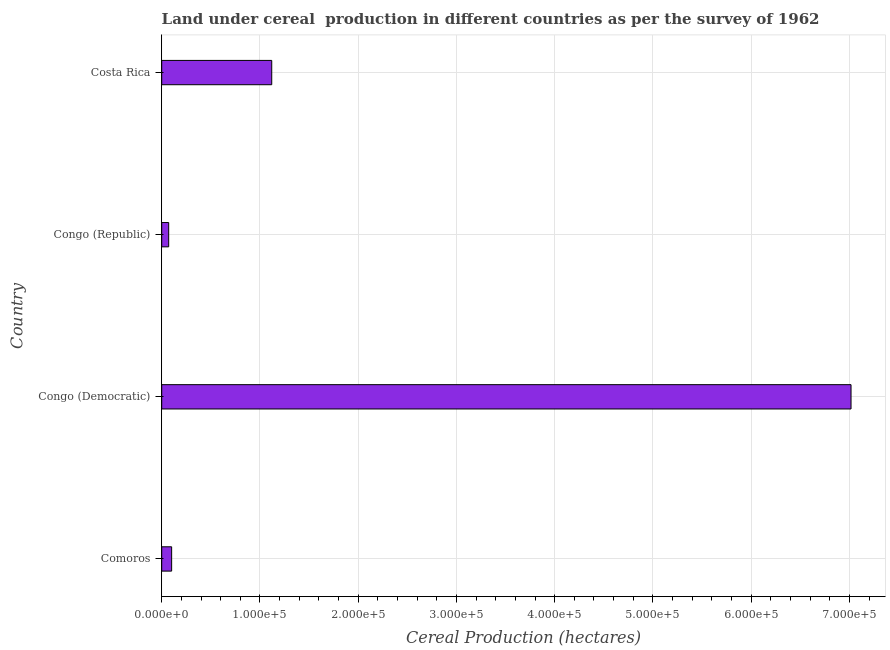What is the title of the graph?
Your answer should be compact. Land under cereal  production in different countries as per the survey of 1962. What is the label or title of the X-axis?
Make the answer very short. Cereal Production (hectares). What is the land under cereal production in Comoros?
Keep it short and to the point. 1.01e+04. Across all countries, what is the maximum land under cereal production?
Offer a terse response. 7.02e+05. Across all countries, what is the minimum land under cereal production?
Make the answer very short. 7100. In which country was the land under cereal production maximum?
Your answer should be compact. Congo (Democratic). In which country was the land under cereal production minimum?
Your answer should be compact. Congo (Republic). What is the sum of the land under cereal production?
Offer a very short reply. 8.31e+05. What is the difference between the land under cereal production in Congo (Democratic) and Congo (Republic)?
Your answer should be very brief. 6.95e+05. What is the average land under cereal production per country?
Your answer should be very brief. 2.08e+05. What is the median land under cereal production?
Offer a terse response. 6.10e+04. In how many countries, is the land under cereal production greater than 100000 hectares?
Provide a succinct answer. 2. What is the ratio of the land under cereal production in Comoros to that in Congo (Democratic)?
Your answer should be very brief. 0.01. Is the land under cereal production in Congo (Democratic) less than that in Congo (Republic)?
Make the answer very short. No. Is the difference between the land under cereal production in Congo (Democratic) and Costa Rica greater than the difference between any two countries?
Give a very brief answer. No. What is the difference between the highest and the second highest land under cereal production?
Ensure brevity in your answer.  5.90e+05. Is the sum of the land under cereal production in Congo (Democratic) and Congo (Republic) greater than the maximum land under cereal production across all countries?
Your answer should be compact. Yes. What is the difference between the highest and the lowest land under cereal production?
Offer a very short reply. 6.95e+05. In how many countries, is the land under cereal production greater than the average land under cereal production taken over all countries?
Offer a very short reply. 1. How many bars are there?
Offer a terse response. 4. Are all the bars in the graph horizontal?
Keep it short and to the point. Yes. What is the difference between two consecutive major ticks on the X-axis?
Offer a very short reply. 1.00e+05. What is the Cereal Production (hectares) in Comoros?
Your response must be concise. 1.01e+04. What is the Cereal Production (hectares) of Congo (Democratic)?
Your response must be concise. 7.02e+05. What is the Cereal Production (hectares) in Congo (Republic)?
Give a very brief answer. 7100. What is the Cereal Production (hectares) in Costa Rica?
Provide a short and direct response. 1.12e+05. What is the difference between the Cereal Production (hectares) in Comoros and Congo (Democratic)?
Offer a very short reply. -6.92e+05. What is the difference between the Cereal Production (hectares) in Comoros and Congo (Republic)?
Provide a short and direct response. 3000. What is the difference between the Cereal Production (hectares) in Comoros and Costa Rica?
Offer a terse response. -1.02e+05. What is the difference between the Cereal Production (hectares) in Congo (Democratic) and Congo (Republic)?
Provide a succinct answer. 6.95e+05. What is the difference between the Cereal Production (hectares) in Congo (Democratic) and Costa Rica?
Keep it short and to the point. 5.90e+05. What is the difference between the Cereal Production (hectares) in Congo (Republic) and Costa Rica?
Give a very brief answer. -1.05e+05. What is the ratio of the Cereal Production (hectares) in Comoros to that in Congo (Democratic)?
Your answer should be very brief. 0.01. What is the ratio of the Cereal Production (hectares) in Comoros to that in Congo (Republic)?
Offer a terse response. 1.42. What is the ratio of the Cereal Production (hectares) in Comoros to that in Costa Rica?
Offer a terse response. 0.09. What is the ratio of the Cereal Production (hectares) in Congo (Democratic) to that in Congo (Republic)?
Your answer should be very brief. 98.83. What is the ratio of the Cereal Production (hectares) in Congo (Democratic) to that in Costa Rica?
Provide a succinct answer. 6.26. What is the ratio of the Cereal Production (hectares) in Congo (Republic) to that in Costa Rica?
Provide a succinct answer. 0.06. 